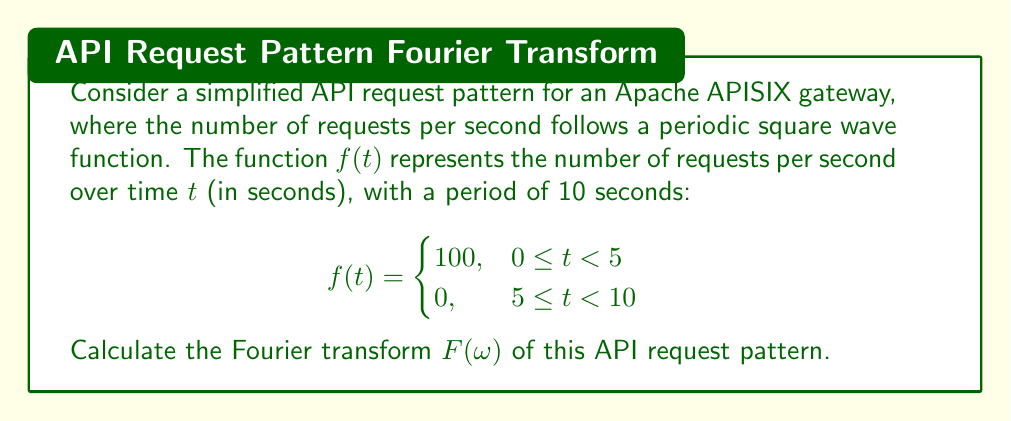Show me your answer to this math problem. To calculate the Fourier transform of the given API request pattern, we'll follow these steps:

1) The Fourier transform of a periodic function is given by:

   $$F(\omega) = \frac{1}{T} \int_{0}^{T} f(t) e^{-i\omega t} dt$$

   where $T$ is the period of the function.

2) In our case, $T = 10$ seconds. We'll split the integral into two parts:

   $$F(\omega) = \frac{1}{10} \left( \int_{0}^{5} 100 e^{-i\omega t} dt + \int_{5}^{10} 0 e^{-i\omega t} dt \right)$$

3) The second integral is zero, so we only need to calculate:

   $$F(\omega) = \frac{10}{10} \int_{0}^{5} e^{-i\omega t} dt$$

4) Evaluating this integral:

   $$F(\omega) = \left. \frac{10}{10} \cdot \frac{-100}{i\omega} e^{-i\omega t} \right|_{0}^{5}$$

5) Substituting the limits:

   $$F(\omega) = \frac{-100}{i\omega} (e^{-5i\omega} - 1)$$

6) Using Euler's formula, $e^{-i\theta} = \cos\theta - i\sin\theta$:

   $$F(\omega) = \frac{100}{i\omega} (1 - \cos(5\omega) + i\sin(5\omega))$$

7) Separating real and imaginary parts:

   $$F(\omega) = 100 \cdot \frac{\sin(5\omega)}{\omega} + i \cdot 100 \cdot \frac{1 - \cos(5\omega)}{\omega}$$

This is the Fourier transform of the API request pattern.
Answer: $$F(\omega) = 100 \cdot \frac{\sin(5\omega)}{\omega} + i \cdot 100 \cdot \frac{1 - \cos(5\omega)}{\omega}$$ 